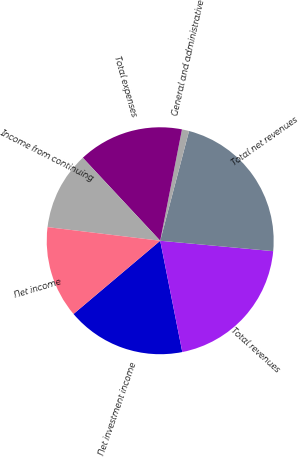Convert chart. <chart><loc_0><loc_0><loc_500><loc_500><pie_chart><fcel>Net investment income<fcel>Total revenues<fcel>Total net revenues<fcel>General and administrative<fcel>Total expenses<fcel>Income from continuing<fcel>Net income<nl><fcel>16.96%<fcel>20.42%<fcel>22.37%<fcel>1.02%<fcel>15.02%<fcel>11.14%<fcel>13.08%<nl></chart> 